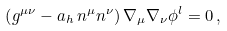Convert formula to latex. <formula><loc_0><loc_0><loc_500><loc_500>\left ( g ^ { \mu \nu } - a _ { h } \, n ^ { \mu } n ^ { \nu } \right ) \nabla _ { \mu } \nabla _ { \nu } \phi ^ { l } = 0 \, ,</formula> 